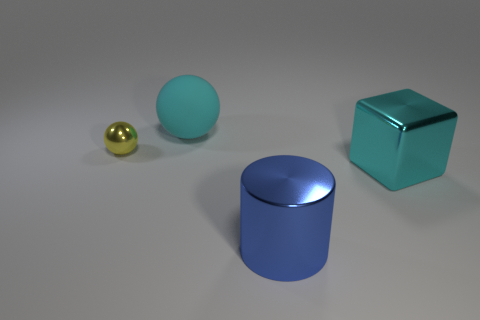There is a large object that is the same color as the large shiny block; what is its shape?
Give a very brief answer. Sphere. The other object that is the same color as the big rubber thing is what size?
Make the answer very short. Large. How many cylinders are tiny things or red matte things?
Provide a succinct answer. 0. How big is the blue object?
Provide a succinct answer. Large. How many cyan matte objects are behind the small ball?
Your response must be concise. 1. What size is the thing to the left of the big cyan object that is behind the big cube?
Your answer should be compact. Small. Is the shape of the big cyan thing that is on the right side of the cyan rubber object the same as the big cyan object that is to the left of the cyan metallic block?
Offer a terse response. No. What is the shape of the large cyan object that is on the left side of the big cyan thing that is in front of the yellow thing?
Your answer should be very brief. Sphere. What is the size of the metal thing that is on the left side of the large cyan metallic object and on the right side of the tiny yellow metallic object?
Provide a short and direct response. Large. There is a big blue shiny object; does it have the same shape as the large metal thing that is behind the large blue metallic thing?
Provide a short and direct response. No. 